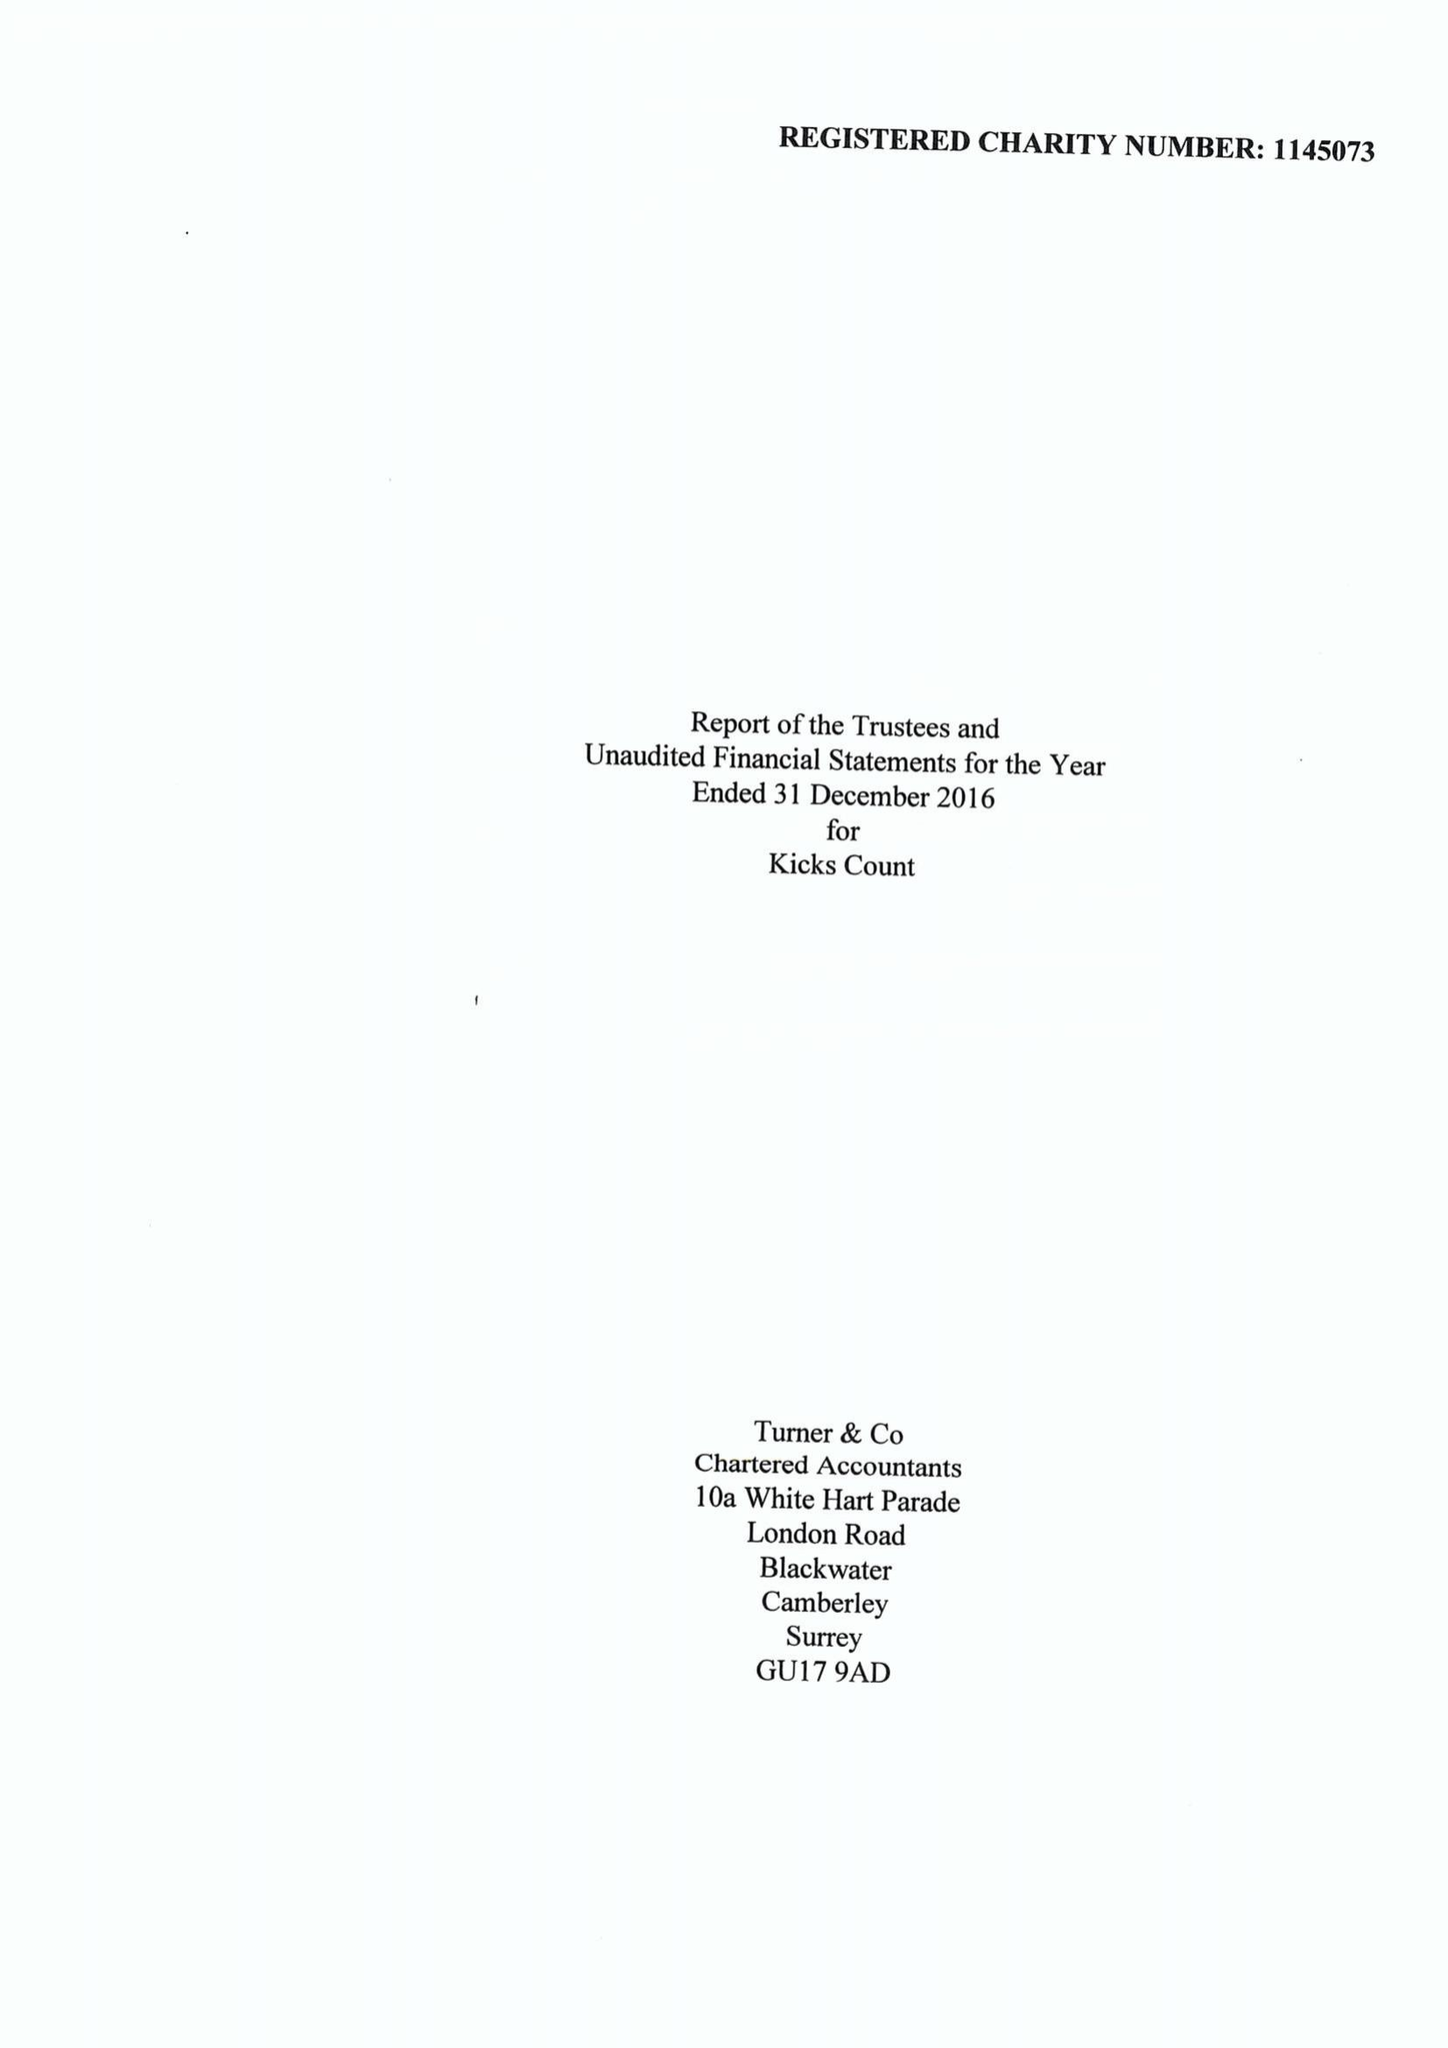What is the value for the address__postcode?
Answer the question using a single word or phrase. GU23 6BN 